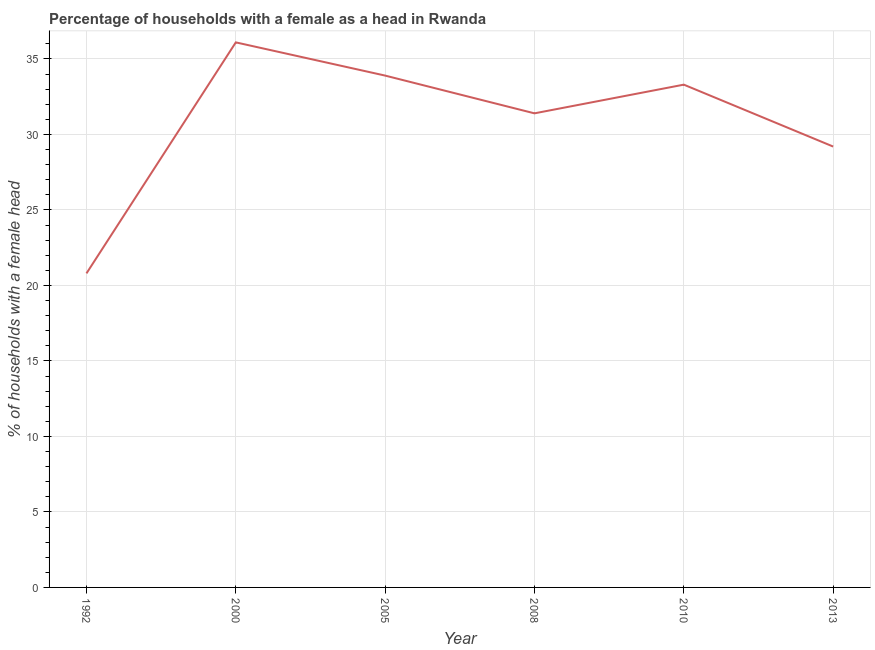What is the number of female supervised households in 2013?
Your response must be concise. 29.2. Across all years, what is the maximum number of female supervised households?
Offer a very short reply. 36.1. Across all years, what is the minimum number of female supervised households?
Your response must be concise. 20.8. In which year was the number of female supervised households maximum?
Make the answer very short. 2000. What is the sum of the number of female supervised households?
Keep it short and to the point. 184.7. What is the difference between the number of female supervised households in 2005 and 2010?
Offer a terse response. 0.6. What is the average number of female supervised households per year?
Give a very brief answer. 30.78. What is the median number of female supervised households?
Provide a succinct answer. 32.35. In how many years, is the number of female supervised households greater than 16 %?
Ensure brevity in your answer.  6. Do a majority of the years between 2000 and 2005 (inclusive) have number of female supervised households greater than 11 %?
Provide a succinct answer. Yes. What is the ratio of the number of female supervised households in 1992 to that in 2008?
Provide a short and direct response. 0.66. Is the number of female supervised households in 1992 less than that in 2000?
Give a very brief answer. Yes. What is the difference between the highest and the second highest number of female supervised households?
Keep it short and to the point. 2.2. Does the number of female supervised households monotonically increase over the years?
Offer a very short reply. No. How many lines are there?
Your answer should be very brief. 1. How many years are there in the graph?
Your answer should be compact. 6. What is the difference between two consecutive major ticks on the Y-axis?
Your answer should be compact. 5. Does the graph contain any zero values?
Provide a succinct answer. No. Does the graph contain grids?
Your answer should be compact. Yes. What is the title of the graph?
Your answer should be compact. Percentage of households with a female as a head in Rwanda. What is the label or title of the X-axis?
Provide a succinct answer. Year. What is the label or title of the Y-axis?
Keep it short and to the point. % of households with a female head. What is the % of households with a female head in 1992?
Ensure brevity in your answer.  20.8. What is the % of households with a female head in 2000?
Your answer should be compact. 36.1. What is the % of households with a female head in 2005?
Give a very brief answer. 33.9. What is the % of households with a female head in 2008?
Ensure brevity in your answer.  31.4. What is the % of households with a female head in 2010?
Ensure brevity in your answer.  33.3. What is the % of households with a female head of 2013?
Offer a very short reply. 29.2. What is the difference between the % of households with a female head in 1992 and 2000?
Offer a very short reply. -15.3. What is the difference between the % of households with a female head in 1992 and 2005?
Provide a succinct answer. -13.1. What is the difference between the % of households with a female head in 1992 and 2008?
Provide a succinct answer. -10.6. What is the difference between the % of households with a female head in 1992 and 2010?
Offer a very short reply. -12.5. What is the difference between the % of households with a female head in 1992 and 2013?
Provide a succinct answer. -8.4. What is the difference between the % of households with a female head in 2000 and 2005?
Your answer should be very brief. 2.2. What is the difference between the % of households with a female head in 2000 and 2008?
Ensure brevity in your answer.  4.7. What is the difference between the % of households with a female head in 2000 and 2010?
Keep it short and to the point. 2.8. What is the difference between the % of households with a female head in 2005 and 2010?
Your answer should be compact. 0.6. What is the difference between the % of households with a female head in 2005 and 2013?
Your response must be concise. 4.7. What is the difference between the % of households with a female head in 2008 and 2010?
Keep it short and to the point. -1.9. What is the difference between the % of households with a female head in 2010 and 2013?
Ensure brevity in your answer.  4.1. What is the ratio of the % of households with a female head in 1992 to that in 2000?
Your response must be concise. 0.58. What is the ratio of the % of households with a female head in 1992 to that in 2005?
Keep it short and to the point. 0.61. What is the ratio of the % of households with a female head in 1992 to that in 2008?
Your answer should be very brief. 0.66. What is the ratio of the % of households with a female head in 1992 to that in 2013?
Give a very brief answer. 0.71. What is the ratio of the % of households with a female head in 2000 to that in 2005?
Keep it short and to the point. 1.06. What is the ratio of the % of households with a female head in 2000 to that in 2008?
Your answer should be very brief. 1.15. What is the ratio of the % of households with a female head in 2000 to that in 2010?
Offer a very short reply. 1.08. What is the ratio of the % of households with a female head in 2000 to that in 2013?
Offer a terse response. 1.24. What is the ratio of the % of households with a female head in 2005 to that in 2008?
Provide a succinct answer. 1.08. What is the ratio of the % of households with a female head in 2005 to that in 2013?
Offer a terse response. 1.16. What is the ratio of the % of households with a female head in 2008 to that in 2010?
Give a very brief answer. 0.94. What is the ratio of the % of households with a female head in 2008 to that in 2013?
Ensure brevity in your answer.  1.07. What is the ratio of the % of households with a female head in 2010 to that in 2013?
Offer a very short reply. 1.14. 